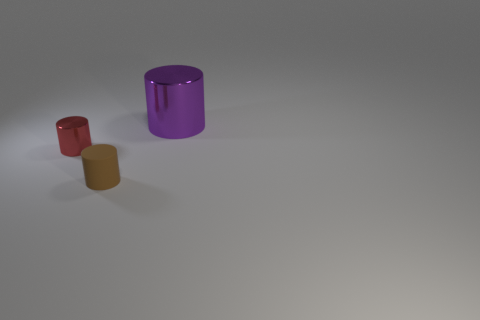Add 3 big shiny cylinders. How many objects exist? 6 Add 1 tiny yellow objects. How many tiny yellow objects exist? 1 Subtract 0 purple balls. How many objects are left? 3 Subtract all large purple metal cylinders. Subtract all tiny brown rubber cylinders. How many objects are left? 1 Add 1 red things. How many red things are left? 2 